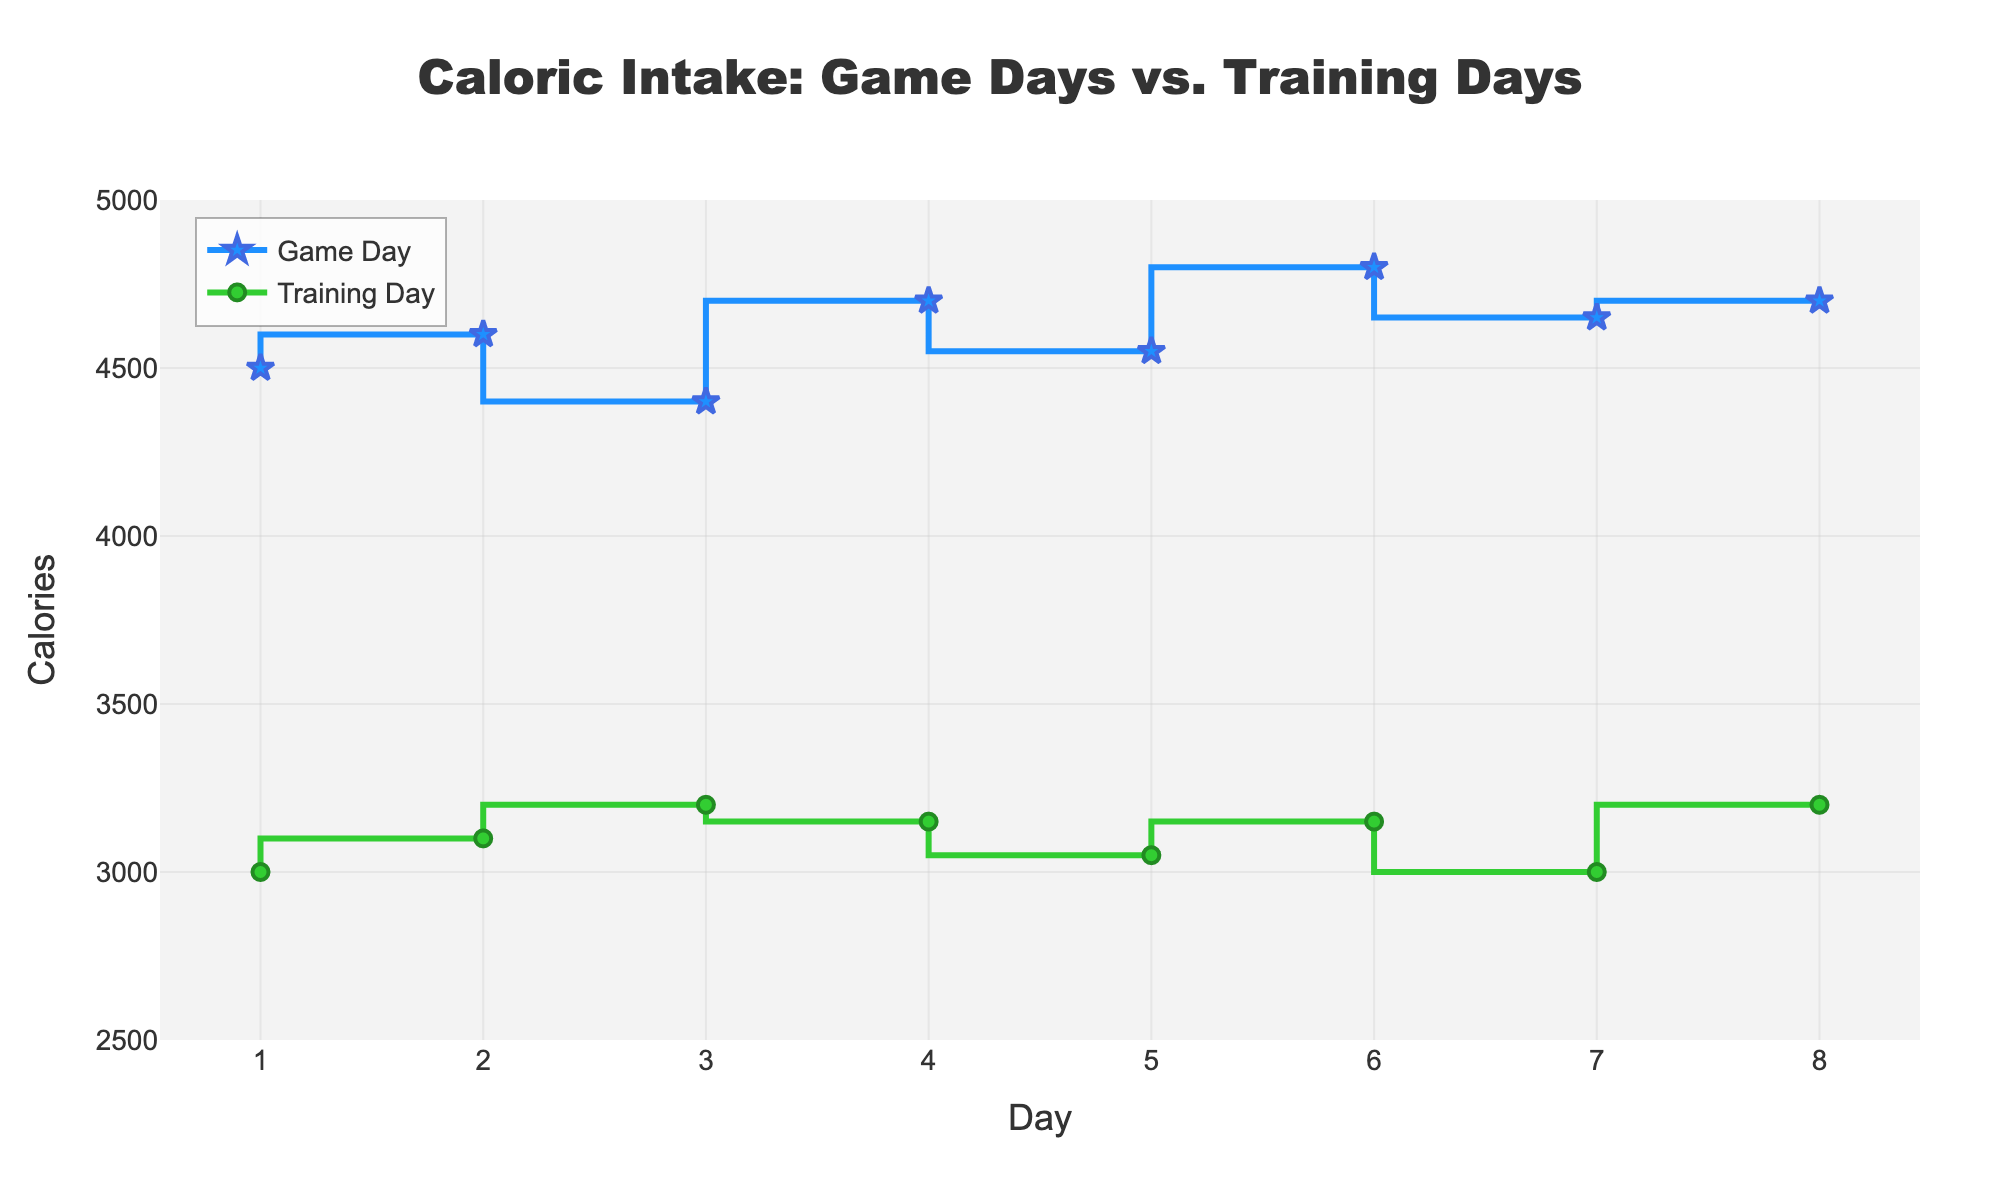What is the title of the plot? The title is displayed at the top center of the plot. It provides a brief summary of the subject of the plot.
Answer: Caloric Intake: Game Days vs. Training Days What are the labels on the x-axis and y-axis? The x-axis label, which is at the bottom of the plot, represents the days, and the y-axis label, which is at the left of the plot, represents the number of calories.
Answer: Day (x-axis) and Calories (y-axis) How many game days are depicted in the plot? By counting the distinct points or markers on the plot specifically on the Game Day line. Each point represents one game day.
Answer: 8 What is the caloric intake on Day 2 for training days? Locate Day 2 on the x-axis and then find the corresponding marker on the line for Training Days, then refer to the y-axis value to get the caloric intake.
Answer: 3100 calories What is the overall trend of caloric intake on game days compared to training days? By looking at the plot, we can observe the general direction of the lines. The Game Day line is generally higher and more varied compared to the Training Day line, indicating higher caloric intake.
Answer: Game days have a higher and more varied caloric intake than training days Which day shows the highest caloric intake on training days? Locate the highest point on the Training Day line and see which day it corresponds to on the x-axis.
Answer: Day 3 What is the average caloric intake on game days? Sum up all the caloric values for Game Days and then divide by the number of game days (8 days). Total sum = 4500 + 4600 + 4400 + 4700 + 4550 + 4800 + 4650 + 4700 = 36900. Average = 36900 / 8.
Answer: 4612.5 calories What is the difference in caloric intake between game days and training days on Day 5? Identify the caloric intake values for both days on Day 5 and subtract the training day value from the game day value. Game Day = 4550, Training Day = 3050. Difference = 4550 - 3050.
Answer: 1500 calories On which days does the caloric intake for training days appear to be constant? Identify the flat sections of the Training Day line where the y-values do not change.
Answer: Days 1 and 7, and Days 4 and 6 How does the variation in caloric intake over days compare between game days and training days? Observe the changes in the y-values over the days for both lines. The Game Day line has steeper and more frequent changes, indicating higher variation, while the Training Day line is less varied and smoother.
Answer: Game days have higher variation in caloric intake compared to training days 